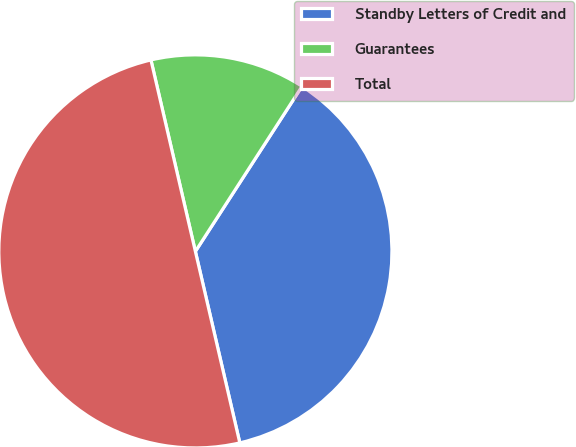Convert chart to OTSL. <chart><loc_0><loc_0><loc_500><loc_500><pie_chart><fcel>Standby Letters of Credit and<fcel>Guarantees<fcel>Total<nl><fcel>37.24%<fcel>12.76%<fcel>50.0%<nl></chart> 